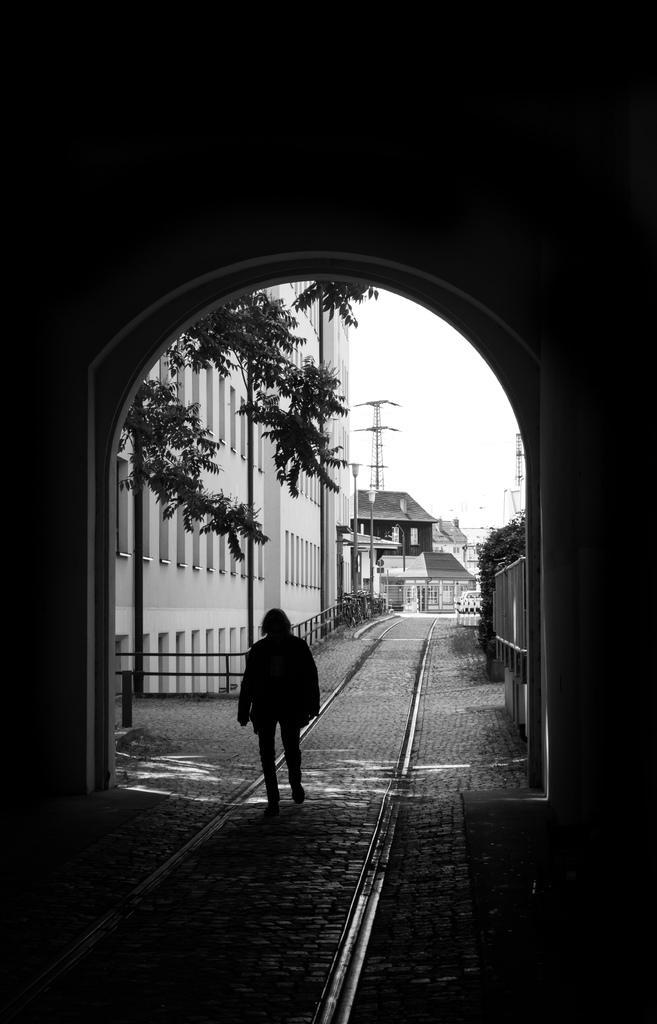Could you give a brief overview of what you see in this image? In the foreground I can see a person on the road. In the background I can see buildings, trees, towers, lights poles and the sky. This image is taken may be on the road. 